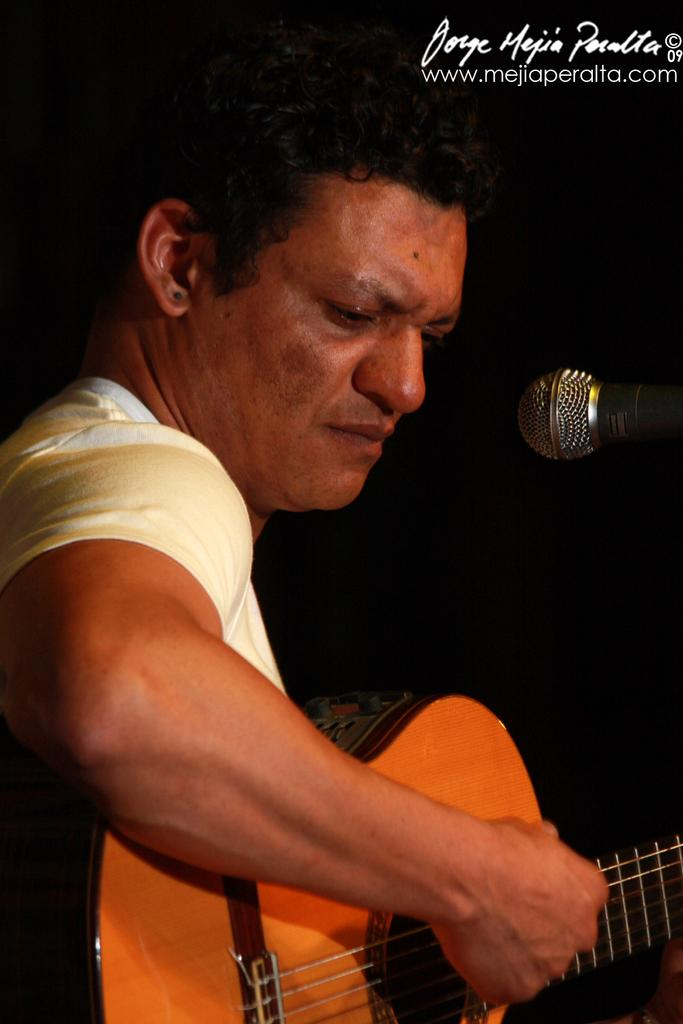What is the man in the image doing? The man is playing a guitar in the image. What object is present in the image that is commonly used for amplifying sound? There is a microphone in the image. What type of show is the man participating in, as indicated by the presence of a microphone in the image? There is no indication of a show in the image; it only shows a man playing a guitar and a microphone. 